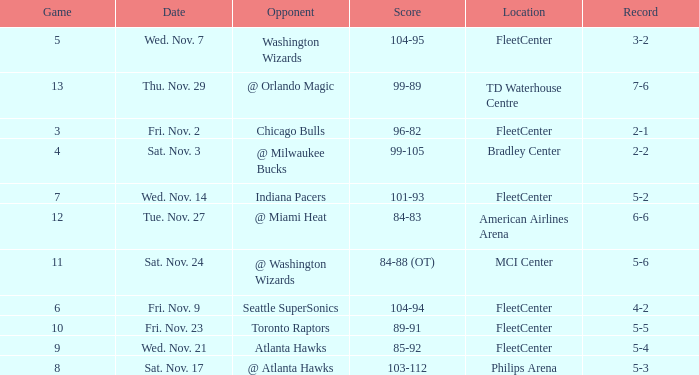On what date did Fleetcenter have a game lower than 9 with a score of 104-94? Fri. Nov. 9. 